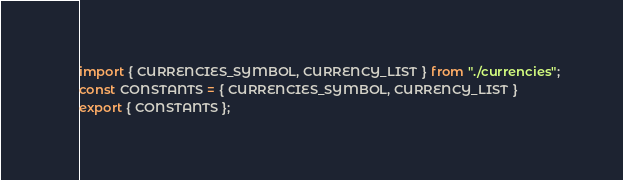<code> <loc_0><loc_0><loc_500><loc_500><_JavaScript_>import { CURRENCIES_SYMBOL, CURRENCY_LIST } from "./currencies";
const CONSTANTS = { CURRENCIES_SYMBOL, CURRENCY_LIST }
export { CONSTANTS };</code> 